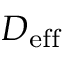Convert formula to latex. <formula><loc_0><loc_0><loc_500><loc_500>D _ { e f f }</formula> 